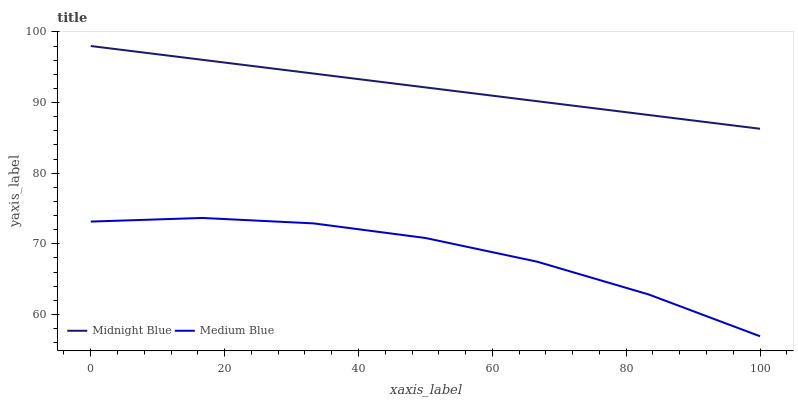Does Medium Blue have the minimum area under the curve?
Answer yes or no. Yes. Does Midnight Blue have the maximum area under the curve?
Answer yes or no. Yes. Does Midnight Blue have the minimum area under the curve?
Answer yes or no. No. Is Midnight Blue the smoothest?
Answer yes or no. Yes. Is Medium Blue the roughest?
Answer yes or no. Yes. Is Midnight Blue the roughest?
Answer yes or no. No. Does Midnight Blue have the lowest value?
Answer yes or no. No. Is Medium Blue less than Midnight Blue?
Answer yes or no. Yes. Is Midnight Blue greater than Medium Blue?
Answer yes or no. Yes. Does Medium Blue intersect Midnight Blue?
Answer yes or no. No. 